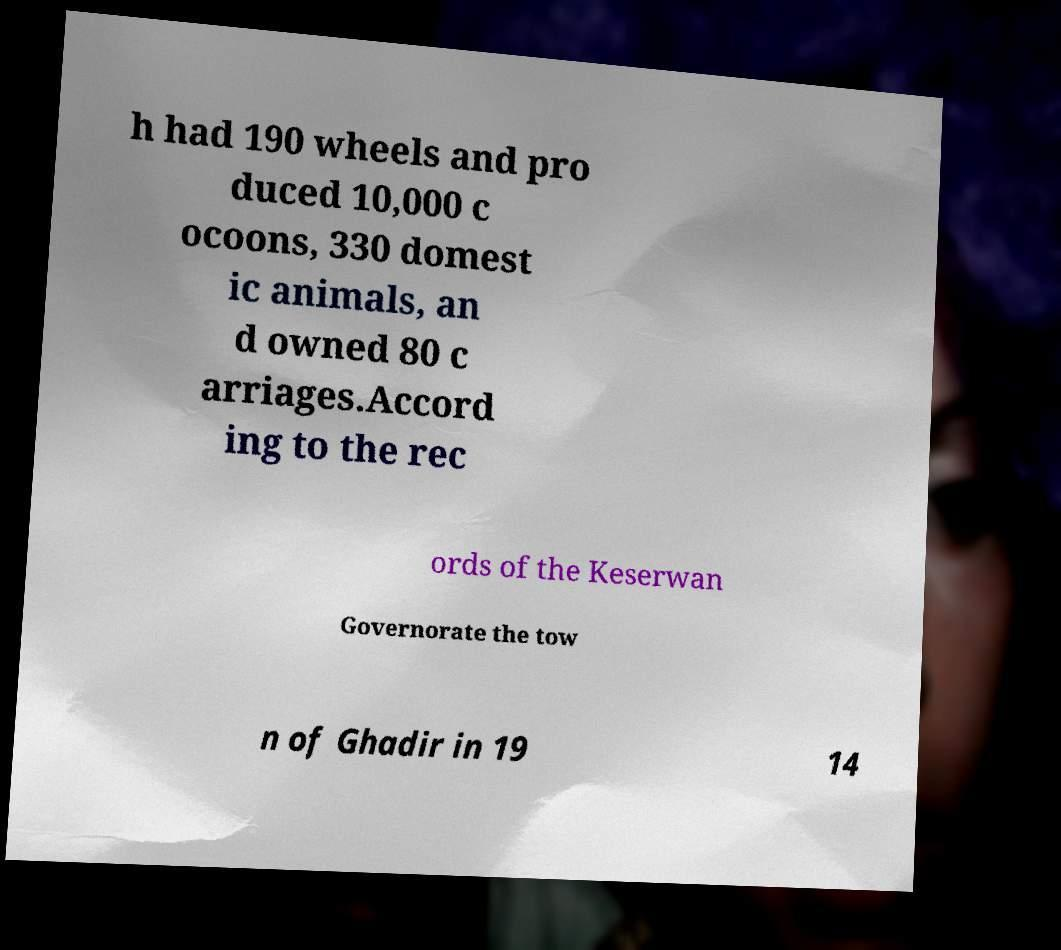Can you accurately transcribe the text from the provided image for me? h had 190 wheels and pro duced 10,000 c ocoons, 330 domest ic animals, an d owned 80 c arriages.Accord ing to the rec ords of the Keserwan Governorate the tow n of Ghadir in 19 14 